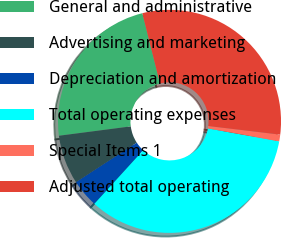Convert chart to OTSL. <chart><loc_0><loc_0><loc_500><loc_500><pie_chart><fcel>General and administrative<fcel>Advertising and marketing<fcel>Depreciation and amortization<fcel>Total operating expenses<fcel>Special Items 1<fcel>Adjusted total operating<nl><fcel>23.14%<fcel>7.13%<fcel>4.05%<fcel>33.89%<fcel>0.97%<fcel>30.81%<nl></chart> 